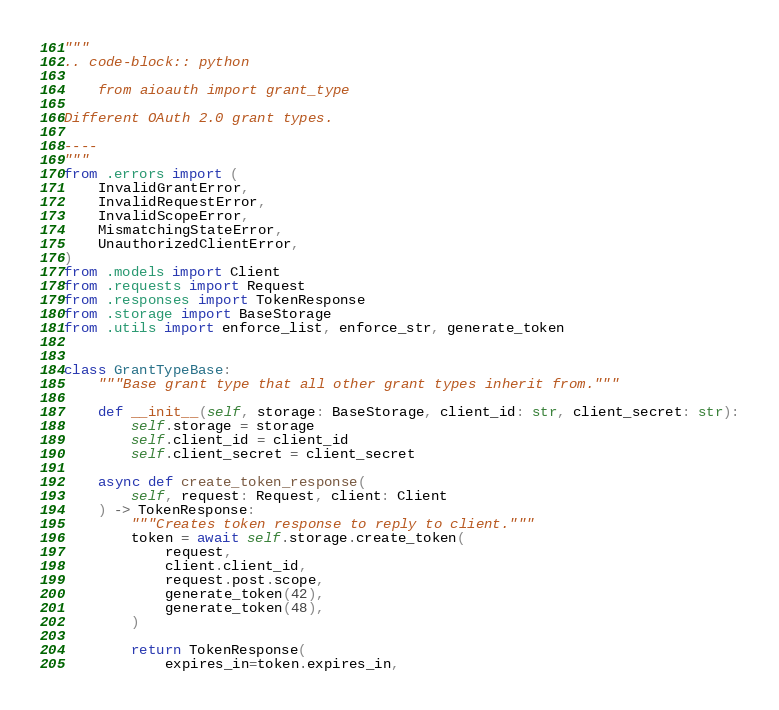<code> <loc_0><loc_0><loc_500><loc_500><_Python_>"""
.. code-block:: python

    from aioauth import grant_type

Different OAuth 2.0 grant types.

----
"""
from .errors import (
    InvalidGrantError,
    InvalidRequestError,
    InvalidScopeError,
    MismatchingStateError,
    UnauthorizedClientError,
)
from .models import Client
from .requests import Request
from .responses import TokenResponse
from .storage import BaseStorage
from .utils import enforce_list, enforce_str, generate_token


class GrantTypeBase:
    """Base grant type that all other grant types inherit from."""

    def __init__(self, storage: BaseStorage, client_id: str, client_secret: str):
        self.storage = storage
        self.client_id = client_id
        self.client_secret = client_secret

    async def create_token_response(
        self, request: Request, client: Client
    ) -> TokenResponse:
        """Creates token response to reply to client."""
        token = await self.storage.create_token(
            request,
            client.client_id,
            request.post.scope,
            generate_token(42),
            generate_token(48),
        )

        return TokenResponse(
            expires_in=token.expires_in,</code> 